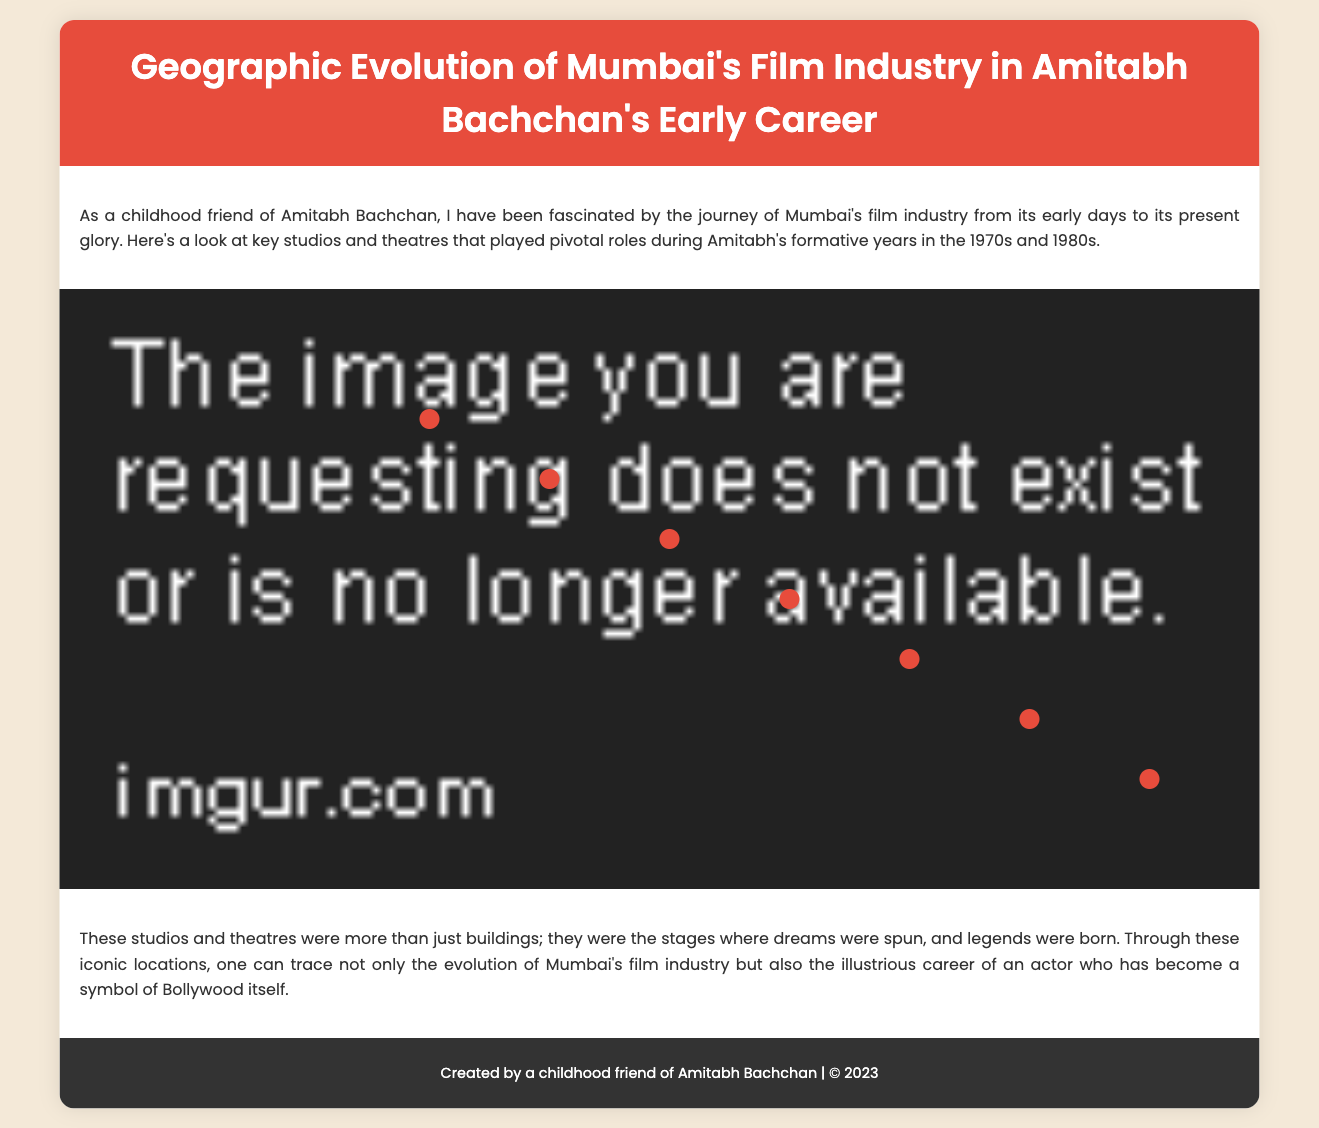What year was Bombay Talkies established? Bombay Talkies was established in 1934, which is clearly stated in the document.
Answer: 1934 What location is Filmistan Studio situated in? The document explicitly states that Filmistan Studio is located in Goregaon, Mumbai.
Answer: Goregaon Who founded RK Studios? The document mentions that RK Studios was founded by the legendary Raj Kapoor.
Answer: Raj Kapoor Which famous film was associated with Mehboob Studio? The document indicates that Amitabh's association with Mehboob Studio includes the film 'Amar Akbar Anthony'.
Answer: Amar Akbar Anthony What is the significance of Maratha Mandir? The document describes Maratha Mandir as a single-screen theatre famous for its long-running shows of Bollywood films.
Answer: Long-running shows of Bollywood films How many years after its establishment did Liberty Cinema host premieres of Amitabh's films? Liberty Cinema was established in 1947, and Amitabh's rise became notable in the 1970s, which means approximately 23 years later.
Answer: 23 years What type of cinema is Eros Cinema described as? The document describes Eros Cinema as one of the premier places to watch the latest Bollywood releases.
Answer: Premier place for Bollywood releases Which studio was established first, Bombay Talkies or Mehboob Studio? The establishment years in the document show that Bombay Talkies was established in 1934, and Mehboob Studio was established in 1954, making Bombay Talkies the first.
Answer: Bombay Talkies What color is used for the location points on the map? The document states that the location points are in the color red.
Answer: Red 